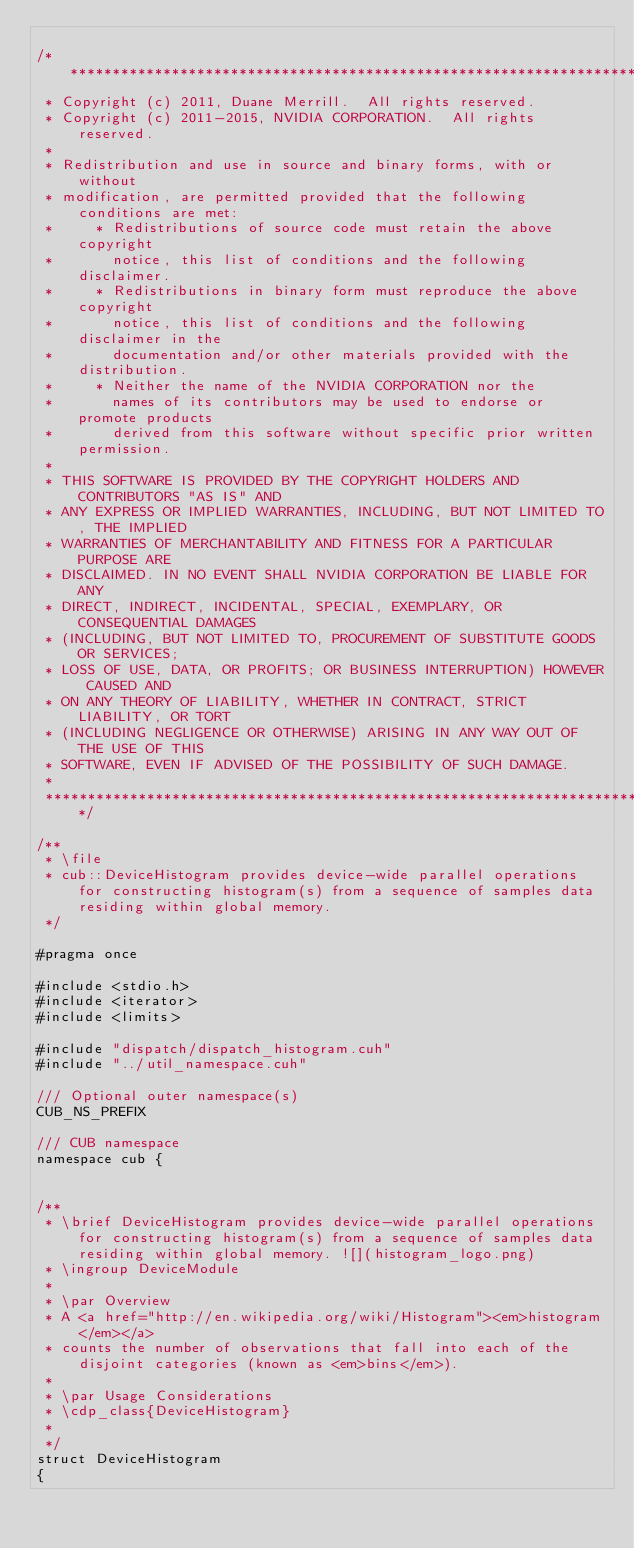<code> <loc_0><loc_0><loc_500><loc_500><_Cuda_>
/******************************************************************************
 * Copyright (c) 2011, Duane Merrill.  All rights reserved.
 * Copyright (c) 2011-2015, NVIDIA CORPORATION.  All rights reserved.
 *
 * Redistribution and use in source and binary forms, with or without
 * modification, are permitted provided that the following conditions are met:
 *     * Redistributions of source code must retain the above copyright
 *       notice, this list of conditions and the following disclaimer.
 *     * Redistributions in binary form must reproduce the above copyright
 *       notice, this list of conditions and the following disclaimer in the
 *       documentation and/or other materials provided with the distribution.
 *     * Neither the name of the NVIDIA CORPORATION nor the
 *       names of its contributors may be used to endorse or promote products
 *       derived from this software without specific prior written permission.
 *
 * THIS SOFTWARE IS PROVIDED BY THE COPYRIGHT HOLDERS AND CONTRIBUTORS "AS IS" AND
 * ANY EXPRESS OR IMPLIED WARRANTIES, INCLUDING, BUT NOT LIMITED TO, THE IMPLIED
 * WARRANTIES OF MERCHANTABILITY AND FITNESS FOR A PARTICULAR PURPOSE ARE
 * DISCLAIMED. IN NO EVENT SHALL NVIDIA CORPORATION BE LIABLE FOR ANY
 * DIRECT, INDIRECT, INCIDENTAL, SPECIAL, EXEMPLARY, OR CONSEQUENTIAL DAMAGES
 * (INCLUDING, BUT NOT LIMITED TO, PROCUREMENT OF SUBSTITUTE GOODS OR SERVICES;
 * LOSS OF USE, DATA, OR PROFITS; OR BUSINESS INTERRUPTION) HOWEVER CAUSED AND
 * ON ANY THEORY OF LIABILITY, WHETHER IN CONTRACT, STRICT LIABILITY, OR TORT
 * (INCLUDING NEGLIGENCE OR OTHERWISE) ARISING IN ANY WAY OUT OF THE USE OF THIS
 * SOFTWARE, EVEN IF ADVISED OF THE POSSIBILITY OF SUCH DAMAGE.
 *
 ******************************************************************************/

/**
 * \file
 * cub::DeviceHistogram provides device-wide parallel operations for constructing histogram(s) from a sequence of samples data residing within global memory.
 */

#pragma once

#include <stdio.h>
#include <iterator>
#include <limits>

#include "dispatch/dispatch_histogram.cuh"
#include "../util_namespace.cuh"

/// Optional outer namespace(s)
CUB_NS_PREFIX

/// CUB namespace
namespace cub {


/**
 * \brief DeviceHistogram provides device-wide parallel operations for constructing histogram(s) from a sequence of samples data residing within global memory. ![](histogram_logo.png)
 * \ingroup DeviceModule
 *
 * \par Overview
 * A <a href="http://en.wikipedia.org/wiki/Histogram"><em>histogram</em></a>
 * counts the number of observations that fall into each of the disjoint categories (known as <em>bins</em>).
 *
 * \par Usage Considerations
 * \cdp_class{DeviceHistogram}
 *
 */
struct DeviceHistogram
{</code> 